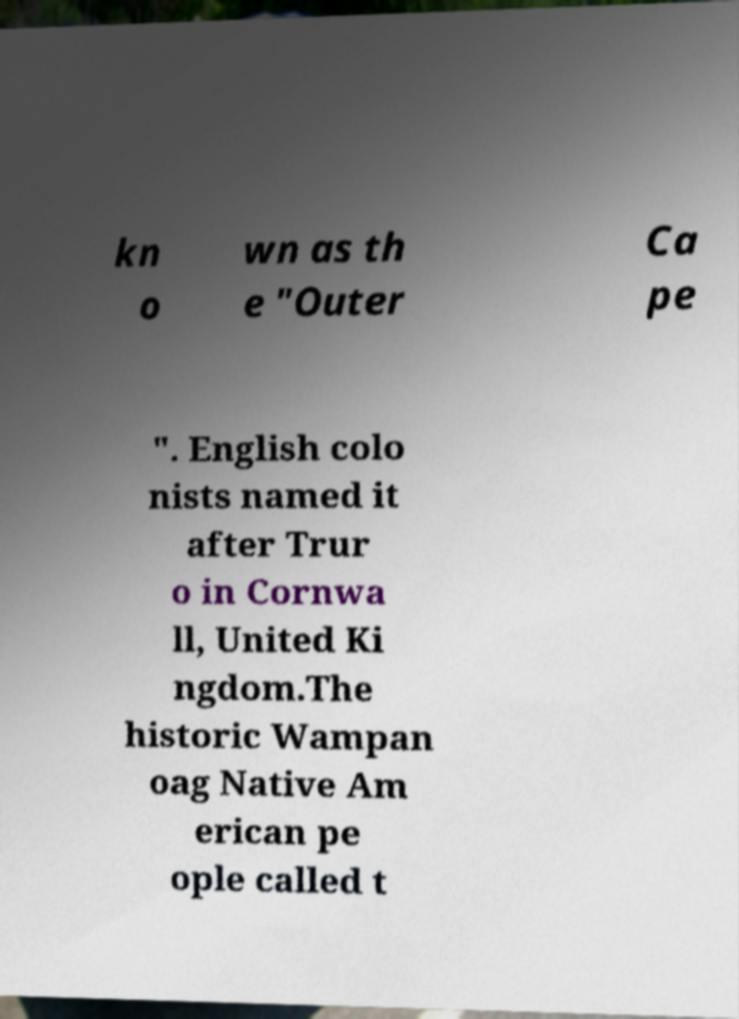There's text embedded in this image that I need extracted. Can you transcribe it verbatim? kn o wn as th e "Outer Ca pe ". English colo nists named it after Trur o in Cornwa ll, United Ki ngdom.The historic Wampan oag Native Am erican pe ople called t 